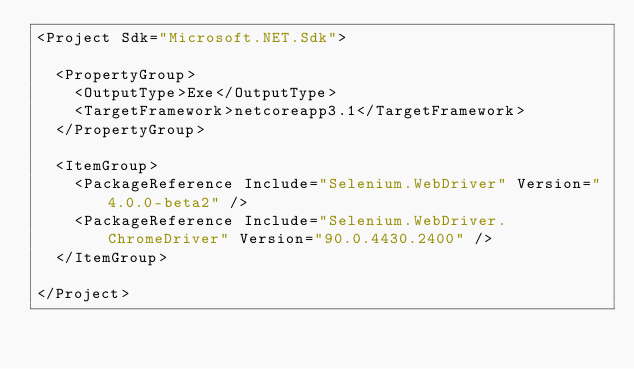Convert code to text. <code><loc_0><loc_0><loc_500><loc_500><_XML_><Project Sdk="Microsoft.NET.Sdk">

  <PropertyGroup>
    <OutputType>Exe</OutputType>
    <TargetFramework>netcoreapp3.1</TargetFramework>
  </PropertyGroup>

  <ItemGroup>
    <PackageReference Include="Selenium.WebDriver" Version="4.0.0-beta2" />
    <PackageReference Include="Selenium.WebDriver.ChromeDriver" Version="90.0.4430.2400" />
  </ItemGroup>

</Project>
</code> 